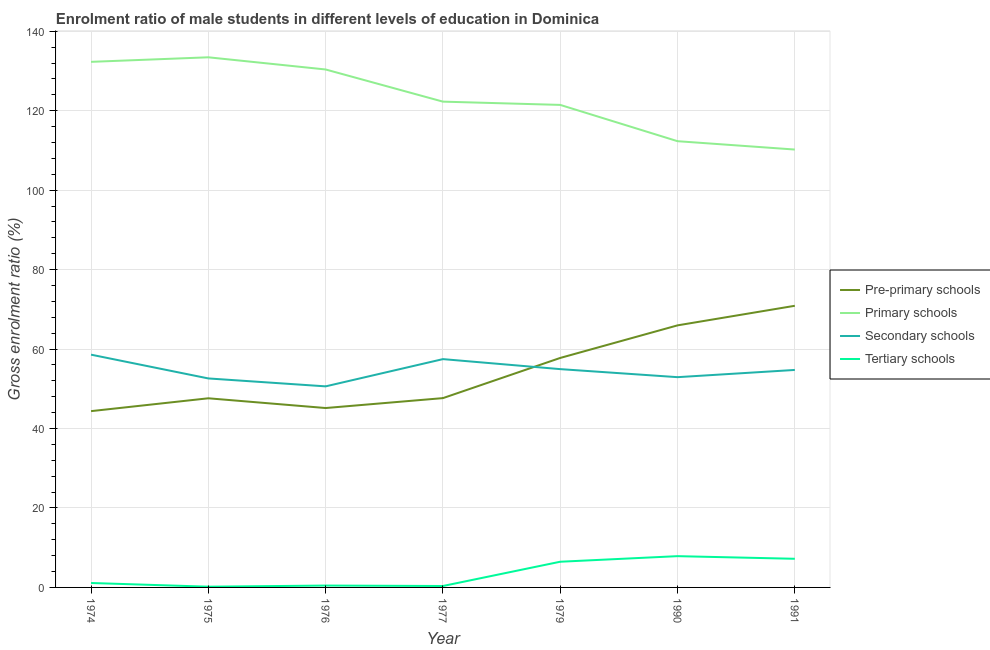Is the number of lines equal to the number of legend labels?
Give a very brief answer. Yes. What is the gross enrolment ratio(female) in pre-primary schools in 1990?
Ensure brevity in your answer.  65.97. Across all years, what is the maximum gross enrolment ratio(female) in primary schools?
Provide a succinct answer. 133.45. Across all years, what is the minimum gross enrolment ratio(female) in pre-primary schools?
Keep it short and to the point. 44.38. In which year was the gross enrolment ratio(female) in tertiary schools maximum?
Offer a terse response. 1990. In which year was the gross enrolment ratio(female) in secondary schools minimum?
Offer a very short reply. 1976. What is the total gross enrolment ratio(female) in secondary schools in the graph?
Make the answer very short. 381.93. What is the difference between the gross enrolment ratio(female) in tertiary schools in 1974 and that in 1976?
Your answer should be compact. 0.64. What is the difference between the gross enrolment ratio(female) in secondary schools in 1975 and the gross enrolment ratio(female) in pre-primary schools in 1974?
Keep it short and to the point. 8.23. What is the average gross enrolment ratio(female) in pre-primary schools per year?
Give a very brief answer. 54.21. In the year 1990, what is the difference between the gross enrolment ratio(female) in secondary schools and gross enrolment ratio(female) in tertiary schools?
Provide a succinct answer. 45.06. In how many years, is the gross enrolment ratio(female) in primary schools greater than 24 %?
Make the answer very short. 7. What is the ratio of the gross enrolment ratio(female) in secondary schools in 1979 to that in 1990?
Your answer should be compact. 1.04. Is the gross enrolment ratio(female) in pre-primary schools in 1975 less than that in 1977?
Keep it short and to the point. Yes. Is the difference between the gross enrolment ratio(female) in tertiary schools in 1974 and 1977 greater than the difference between the gross enrolment ratio(female) in pre-primary schools in 1974 and 1977?
Offer a terse response. Yes. What is the difference between the highest and the second highest gross enrolment ratio(female) in tertiary schools?
Your response must be concise. 0.66. What is the difference between the highest and the lowest gross enrolment ratio(female) in secondary schools?
Offer a terse response. 7.98. In how many years, is the gross enrolment ratio(female) in pre-primary schools greater than the average gross enrolment ratio(female) in pre-primary schools taken over all years?
Give a very brief answer. 3. Is it the case that in every year, the sum of the gross enrolment ratio(female) in pre-primary schools and gross enrolment ratio(female) in primary schools is greater than the gross enrolment ratio(female) in secondary schools?
Provide a succinct answer. Yes. Does the gross enrolment ratio(female) in tertiary schools monotonically increase over the years?
Give a very brief answer. No. Is the gross enrolment ratio(female) in primary schools strictly greater than the gross enrolment ratio(female) in tertiary schools over the years?
Your answer should be very brief. Yes. Is the gross enrolment ratio(female) in primary schools strictly less than the gross enrolment ratio(female) in pre-primary schools over the years?
Ensure brevity in your answer.  No. How many lines are there?
Provide a succinct answer. 4. How many years are there in the graph?
Provide a succinct answer. 7. Does the graph contain any zero values?
Make the answer very short. No. Where does the legend appear in the graph?
Give a very brief answer. Center right. How are the legend labels stacked?
Provide a short and direct response. Vertical. What is the title of the graph?
Your answer should be compact. Enrolment ratio of male students in different levels of education in Dominica. What is the label or title of the Y-axis?
Keep it short and to the point. Gross enrolment ratio (%). What is the Gross enrolment ratio (%) of Pre-primary schools in 1974?
Your answer should be very brief. 44.38. What is the Gross enrolment ratio (%) in Primary schools in 1974?
Provide a succinct answer. 132.31. What is the Gross enrolment ratio (%) of Secondary schools in 1974?
Keep it short and to the point. 58.59. What is the Gross enrolment ratio (%) of Tertiary schools in 1974?
Your answer should be compact. 1.11. What is the Gross enrolment ratio (%) in Pre-primary schools in 1975?
Keep it short and to the point. 47.61. What is the Gross enrolment ratio (%) of Primary schools in 1975?
Offer a terse response. 133.45. What is the Gross enrolment ratio (%) in Secondary schools in 1975?
Keep it short and to the point. 52.61. What is the Gross enrolment ratio (%) of Tertiary schools in 1975?
Offer a terse response. 0.19. What is the Gross enrolment ratio (%) in Pre-primary schools in 1976?
Your answer should be very brief. 45.16. What is the Gross enrolment ratio (%) in Primary schools in 1976?
Your response must be concise. 130.39. What is the Gross enrolment ratio (%) in Secondary schools in 1976?
Give a very brief answer. 50.62. What is the Gross enrolment ratio (%) in Tertiary schools in 1976?
Keep it short and to the point. 0.47. What is the Gross enrolment ratio (%) of Pre-primary schools in 1977?
Offer a very short reply. 47.66. What is the Gross enrolment ratio (%) in Primary schools in 1977?
Provide a short and direct response. 122.29. What is the Gross enrolment ratio (%) in Secondary schools in 1977?
Provide a succinct answer. 57.47. What is the Gross enrolment ratio (%) of Tertiary schools in 1977?
Keep it short and to the point. 0.36. What is the Gross enrolment ratio (%) of Pre-primary schools in 1979?
Provide a succinct answer. 57.77. What is the Gross enrolment ratio (%) in Primary schools in 1979?
Offer a terse response. 121.47. What is the Gross enrolment ratio (%) of Secondary schools in 1979?
Ensure brevity in your answer.  54.95. What is the Gross enrolment ratio (%) of Tertiary schools in 1979?
Ensure brevity in your answer.  6.47. What is the Gross enrolment ratio (%) of Pre-primary schools in 1990?
Keep it short and to the point. 65.97. What is the Gross enrolment ratio (%) of Primary schools in 1990?
Give a very brief answer. 112.33. What is the Gross enrolment ratio (%) of Secondary schools in 1990?
Make the answer very short. 52.93. What is the Gross enrolment ratio (%) of Tertiary schools in 1990?
Your answer should be compact. 7.87. What is the Gross enrolment ratio (%) in Pre-primary schools in 1991?
Offer a very short reply. 70.9. What is the Gross enrolment ratio (%) of Primary schools in 1991?
Make the answer very short. 110.23. What is the Gross enrolment ratio (%) in Secondary schools in 1991?
Provide a short and direct response. 54.75. What is the Gross enrolment ratio (%) in Tertiary schools in 1991?
Provide a short and direct response. 7.21. Across all years, what is the maximum Gross enrolment ratio (%) of Pre-primary schools?
Your answer should be compact. 70.9. Across all years, what is the maximum Gross enrolment ratio (%) of Primary schools?
Make the answer very short. 133.45. Across all years, what is the maximum Gross enrolment ratio (%) in Secondary schools?
Make the answer very short. 58.59. Across all years, what is the maximum Gross enrolment ratio (%) in Tertiary schools?
Offer a very short reply. 7.87. Across all years, what is the minimum Gross enrolment ratio (%) of Pre-primary schools?
Give a very brief answer. 44.38. Across all years, what is the minimum Gross enrolment ratio (%) in Primary schools?
Your answer should be compact. 110.23. Across all years, what is the minimum Gross enrolment ratio (%) in Secondary schools?
Ensure brevity in your answer.  50.62. Across all years, what is the minimum Gross enrolment ratio (%) of Tertiary schools?
Provide a short and direct response. 0.19. What is the total Gross enrolment ratio (%) of Pre-primary schools in the graph?
Provide a succinct answer. 379.45. What is the total Gross enrolment ratio (%) of Primary schools in the graph?
Make the answer very short. 862.47. What is the total Gross enrolment ratio (%) in Secondary schools in the graph?
Give a very brief answer. 381.93. What is the total Gross enrolment ratio (%) in Tertiary schools in the graph?
Offer a terse response. 23.68. What is the difference between the Gross enrolment ratio (%) in Pre-primary schools in 1974 and that in 1975?
Give a very brief answer. -3.23. What is the difference between the Gross enrolment ratio (%) of Primary schools in 1974 and that in 1975?
Offer a terse response. -1.15. What is the difference between the Gross enrolment ratio (%) in Secondary schools in 1974 and that in 1975?
Offer a terse response. 5.99. What is the difference between the Gross enrolment ratio (%) of Tertiary schools in 1974 and that in 1975?
Offer a terse response. 0.93. What is the difference between the Gross enrolment ratio (%) of Pre-primary schools in 1974 and that in 1976?
Offer a very short reply. -0.78. What is the difference between the Gross enrolment ratio (%) of Primary schools in 1974 and that in 1976?
Keep it short and to the point. 1.92. What is the difference between the Gross enrolment ratio (%) in Secondary schools in 1974 and that in 1976?
Offer a very short reply. 7.98. What is the difference between the Gross enrolment ratio (%) of Tertiary schools in 1974 and that in 1976?
Provide a short and direct response. 0.64. What is the difference between the Gross enrolment ratio (%) of Pre-primary schools in 1974 and that in 1977?
Give a very brief answer. -3.28. What is the difference between the Gross enrolment ratio (%) of Primary schools in 1974 and that in 1977?
Your response must be concise. 10.02. What is the difference between the Gross enrolment ratio (%) in Secondary schools in 1974 and that in 1977?
Your response must be concise. 1.12. What is the difference between the Gross enrolment ratio (%) in Tertiary schools in 1974 and that in 1977?
Provide a succinct answer. 0.76. What is the difference between the Gross enrolment ratio (%) of Pre-primary schools in 1974 and that in 1979?
Provide a short and direct response. -13.39. What is the difference between the Gross enrolment ratio (%) in Primary schools in 1974 and that in 1979?
Make the answer very short. 10.84. What is the difference between the Gross enrolment ratio (%) of Secondary schools in 1974 and that in 1979?
Ensure brevity in your answer.  3.64. What is the difference between the Gross enrolment ratio (%) of Tertiary schools in 1974 and that in 1979?
Provide a succinct answer. -5.35. What is the difference between the Gross enrolment ratio (%) of Pre-primary schools in 1974 and that in 1990?
Your answer should be very brief. -21.59. What is the difference between the Gross enrolment ratio (%) in Primary schools in 1974 and that in 1990?
Your response must be concise. 19.97. What is the difference between the Gross enrolment ratio (%) of Secondary schools in 1974 and that in 1990?
Make the answer very short. 5.66. What is the difference between the Gross enrolment ratio (%) in Tertiary schools in 1974 and that in 1990?
Give a very brief answer. -6.76. What is the difference between the Gross enrolment ratio (%) in Pre-primary schools in 1974 and that in 1991?
Ensure brevity in your answer.  -26.52. What is the difference between the Gross enrolment ratio (%) of Primary schools in 1974 and that in 1991?
Provide a succinct answer. 22.08. What is the difference between the Gross enrolment ratio (%) of Secondary schools in 1974 and that in 1991?
Offer a terse response. 3.85. What is the difference between the Gross enrolment ratio (%) of Tertiary schools in 1974 and that in 1991?
Make the answer very short. -6.1. What is the difference between the Gross enrolment ratio (%) of Pre-primary schools in 1975 and that in 1976?
Keep it short and to the point. 2.45. What is the difference between the Gross enrolment ratio (%) of Primary schools in 1975 and that in 1976?
Offer a terse response. 3.07. What is the difference between the Gross enrolment ratio (%) in Secondary schools in 1975 and that in 1976?
Give a very brief answer. 1.99. What is the difference between the Gross enrolment ratio (%) in Tertiary schools in 1975 and that in 1976?
Provide a short and direct response. -0.28. What is the difference between the Gross enrolment ratio (%) in Pre-primary schools in 1975 and that in 1977?
Keep it short and to the point. -0.04. What is the difference between the Gross enrolment ratio (%) in Primary schools in 1975 and that in 1977?
Provide a short and direct response. 11.16. What is the difference between the Gross enrolment ratio (%) of Secondary schools in 1975 and that in 1977?
Offer a very short reply. -4.86. What is the difference between the Gross enrolment ratio (%) in Tertiary schools in 1975 and that in 1977?
Ensure brevity in your answer.  -0.17. What is the difference between the Gross enrolment ratio (%) in Pre-primary schools in 1975 and that in 1979?
Offer a terse response. -10.16. What is the difference between the Gross enrolment ratio (%) in Primary schools in 1975 and that in 1979?
Provide a succinct answer. 11.98. What is the difference between the Gross enrolment ratio (%) of Secondary schools in 1975 and that in 1979?
Provide a short and direct response. -2.34. What is the difference between the Gross enrolment ratio (%) of Tertiary schools in 1975 and that in 1979?
Provide a succinct answer. -6.28. What is the difference between the Gross enrolment ratio (%) in Pre-primary schools in 1975 and that in 1990?
Keep it short and to the point. -18.36. What is the difference between the Gross enrolment ratio (%) in Primary schools in 1975 and that in 1990?
Your response must be concise. 21.12. What is the difference between the Gross enrolment ratio (%) of Secondary schools in 1975 and that in 1990?
Provide a succinct answer. -0.32. What is the difference between the Gross enrolment ratio (%) of Tertiary schools in 1975 and that in 1990?
Make the answer very short. -7.69. What is the difference between the Gross enrolment ratio (%) in Pre-primary schools in 1975 and that in 1991?
Your answer should be very brief. -23.29. What is the difference between the Gross enrolment ratio (%) in Primary schools in 1975 and that in 1991?
Give a very brief answer. 23.22. What is the difference between the Gross enrolment ratio (%) in Secondary schools in 1975 and that in 1991?
Offer a terse response. -2.14. What is the difference between the Gross enrolment ratio (%) in Tertiary schools in 1975 and that in 1991?
Offer a terse response. -7.03. What is the difference between the Gross enrolment ratio (%) in Pre-primary schools in 1976 and that in 1977?
Offer a terse response. -2.5. What is the difference between the Gross enrolment ratio (%) in Primary schools in 1976 and that in 1977?
Offer a very short reply. 8.1. What is the difference between the Gross enrolment ratio (%) of Secondary schools in 1976 and that in 1977?
Offer a very short reply. -6.86. What is the difference between the Gross enrolment ratio (%) of Tertiary schools in 1976 and that in 1977?
Offer a terse response. 0.11. What is the difference between the Gross enrolment ratio (%) in Pre-primary schools in 1976 and that in 1979?
Your response must be concise. -12.61. What is the difference between the Gross enrolment ratio (%) in Primary schools in 1976 and that in 1979?
Give a very brief answer. 8.92. What is the difference between the Gross enrolment ratio (%) in Secondary schools in 1976 and that in 1979?
Provide a succinct answer. -4.34. What is the difference between the Gross enrolment ratio (%) of Tertiary schools in 1976 and that in 1979?
Offer a terse response. -6. What is the difference between the Gross enrolment ratio (%) of Pre-primary schools in 1976 and that in 1990?
Give a very brief answer. -20.81. What is the difference between the Gross enrolment ratio (%) in Primary schools in 1976 and that in 1990?
Provide a succinct answer. 18.05. What is the difference between the Gross enrolment ratio (%) of Secondary schools in 1976 and that in 1990?
Ensure brevity in your answer.  -2.31. What is the difference between the Gross enrolment ratio (%) of Tertiary schools in 1976 and that in 1990?
Provide a succinct answer. -7.4. What is the difference between the Gross enrolment ratio (%) in Pre-primary schools in 1976 and that in 1991?
Your response must be concise. -25.74. What is the difference between the Gross enrolment ratio (%) of Primary schools in 1976 and that in 1991?
Give a very brief answer. 20.16. What is the difference between the Gross enrolment ratio (%) in Secondary schools in 1976 and that in 1991?
Your answer should be very brief. -4.13. What is the difference between the Gross enrolment ratio (%) of Tertiary schools in 1976 and that in 1991?
Ensure brevity in your answer.  -6.74. What is the difference between the Gross enrolment ratio (%) of Pre-primary schools in 1977 and that in 1979?
Provide a succinct answer. -10.11. What is the difference between the Gross enrolment ratio (%) of Primary schools in 1977 and that in 1979?
Your answer should be very brief. 0.82. What is the difference between the Gross enrolment ratio (%) in Secondary schools in 1977 and that in 1979?
Make the answer very short. 2.52. What is the difference between the Gross enrolment ratio (%) of Tertiary schools in 1977 and that in 1979?
Keep it short and to the point. -6.11. What is the difference between the Gross enrolment ratio (%) of Pre-primary schools in 1977 and that in 1990?
Give a very brief answer. -18.31. What is the difference between the Gross enrolment ratio (%) in Primary schools in 1977 and that in 1990?
Ensure brevity in your answer.  9.96. What is the difference between the Gross enrolment ratio (%) in Secondary schools in 1977 and that in 1990?
Give a very brief answer. 4.54. What is the difference between the Gross enrolment ratio (%) in Tertiary schools in 1977 and that in 1990?
Offer a terse response. -7.51. What is the difference between the Gross enrolment ratio (%) of Pre-primary schools in 1977 and that in 1991?
Provide a succinct answer. -23.24. What is the difference between the Gross enrolment ratio (%) of Primary schools in 1977 and that in 1991?
Provide a succinct answer. 12.06. What is the difference between the Gross enrolment ratio (%) of Secondary schools in 1977 and that in 1991?
Provide a succinct answer. 2.72. What is the difference between the Gross enrolment ratio (%) in Tertiary schools in 1977 and that in 1991?
Offer a very short reply. -6.85. What is the difference between the Gross enrolment ratio (%) of Pre-primary schools in 1979 and that in 1990?
Keep it short and to the point. -8.2. What is the difference between the Gross enrolment ratio (%) of Primary schools in 1979 and that in 1990?
Your response must be concise. 9.14. What is the difference between the Gross enrolment ratio (%) of Secondary schools in 1979 and that in 1990?
Give a very brief answer. 2.02. What is the difference between the Gross enrolment ratio (%) in Tertiary schools in 1979 and that in 1990?
Your answer should be compact. -1.4. What is the difference between the Gross enrolment ratio (%) of Pre-primary schools in 1979 and that in 1991?
Make the answer very short. -13.13. What is the difference between the Gross enrolment ratio (%) of Primary schools in 1979 and that in 1991?
Your answer should be very brief. 11.24. What is the difference between the Gross enrolment ratio (%) in Secondary schools in 1979 and that in 1991?
Keep it short and to the point. 0.2. What is the difference between the Gross enrolment ratio (%) in Tertiary schools in 1979 and that in 1991?
Make the answer very short. -0.74. What is the difference between the Gross enrolment ratio (%) of Pre-primary schools in 1990 and that in 1991?
Offer a terse response. -4.93. What is the difference between the Gross enrolment ratio (%) in Primary schools in 1990 and that in 1991?
Your answer should be compact. 2.1. What is the difference between the Gross enrolment ratio (%) in Secondary schools in 1990 and that in 1991?
Offer a very short reply. -1.82. What is the difference between the Gross enrolment ratio (%) in Tertiary schools in 1990 and that in 1991?
Your response must be concise. 0.66. What is the difference between the Gross enrolment ratio (%) in Pre-primary schools in 1974 and the Gross enrolment ratio (%) in Primary schools in 1975?
Your response must be concise. -89.07. What is the difference between the Gross enrolment ratio (%) in Pre-primary schools in 1974 and the Gross enrolment ratio (%) in Secondary schools in 1975?
Offer a terse response. -8.23. What is the difference between the Gross enrolment ratio (%) in Pre-primary schools in 1974 and the Gross enrolment ratio (%) in Tertiary schools in 1975?
Give a very brief answer. 44.19. What is the difference between the Gross enrolment ratio (%) in Primary schools in 1974 and the Gross enrolment ratio (%) in Secondary schools in 1975?
Keep it short and to the point. 79.7. What is the difference between the Gross enrolment ratio (%) in Primary schools in 1974 and the Gross enrolment ratio (%) in Tertiary schools in 1975?
Your answer should be very brief. 132.12. What is the difference between the Gross enrolment ratio (%) of Secondary schools in 1974 and the Gross enrolment ratio (%) of Tertiary schools in 1975?
Provide a short and direct response. 58.41. What is the difference between the Gross enrolment ratio (%) in Pre-primary schools in 1974 and the Gross enrolment ratio (%) in Primary schools in 1976?
Offer a terse response. -86.01. What is the difference between the Gross enrolment ratio (%) of Pre-primary schools in 1974 and the Gross enrolment ratio (%) of Secondary schools in 1976?
Provide a succinct answer. -6.24. What is the difference between the Gross enrolment ratio (%) of Pre-primary schools in 1974 and the Gross enrolment ratio (%) of Tertiary schools in 1976?
Your response must be concise. 43.91. What is the difference between the Gross enrolment ratio (%) of Primary schools in 1974 and the Gross enrolment ratio (%) of Secondary schools in 1976?
Offer a terse response. 81.69. What is the difference between the Gross enrolment ratio (%) of Primary schools in 1974 and the Gross enrolment ratio (%) of Tertiary schools in 1976?
Your answer should be very brief. 131.84. What is the difference between the Gross enrolment ratio (%) of Secondary schools in 1974 and the Gross enrolment ratio (%) of Tertiary schools in 1976?
Offer a very short reply. 58.12. What is the difference between the Gross enrolment ratio (%) in Pre-primary schools in 1974 and the Gross enrolment ratio (%) in Primary schools in 1977?
Make the answer very short. -77.91. What is the difference between the Gross enrolment ratio (%) in Pre-primary schools in 1974 and the Gross enrolment ratio (%) in Secondary schools in 1977?
Your answer should be compact. -13.09. What is the difference between the Gross enrolment ratio (%) in Pre-primary schools in 1974 and the Gross enrolment ratio (%) in Tertiary schools in 1977?
Offer a terse response. 44.02. What is the difference between the Gross enrolment ratio (%) of Primary schools in 1974 and the Gross enrolment ratio (%) of Secondary schools in 1977?
Give a very brief answer. 74.83. What is the difference between the Gross enrolment ratio (%) in Primary schools in 1974 and the Gross enrolment ratio (%) in Tertiary schools in 1977?
Provide a succinct answer. 131.95. What is the difference between the Gross enrolment ratio (%) of Secondary schools in 1974 and the Gross enrolment ratio (%) of Tertiary schools in 1977?
Make the answer very short. 58.24. What is the difference between the Gross enrolment ratio (%) in Pre-primary schools in 1974 and the Gross enrolment ratio (%) in Primary schools in 1979?
Make the answer very short. -77.09. What is the difference between the Gross enrolment ratio (%) in Pre-primary schools in 1974 and the Gross enrolment ratio (%) in Secondary schools in 1979?
Your answer should be compact. -10.57. What is the difference between the Gross enrolment ratio (%) of Pre-primary schools in 1974 and the Gross enrolment ratio (%) of Tertiary schools in 1979?
Give a very brief answer. 37.91. What is the difference between the Gross enrolment ratio (%) of Primary schools in 1974 and the Gross enrolment ratio (%) of Secondary schools in 1979?
Your answer should be compact. 77.35. What is the difference between the Gross enrolment ratio (%) in Primary schools in 1974 and the Gross enrolment ratio (%) in Tertiary schools in 1979?
Offer a terse response. 125.84. What is the difference between the Gross enrolment ratio (%) in Secondary schools in 1974 and the Gross enrolment ratio (%) in Tertiary schools in 1979?
Keep it short and to the point. 52.13. What is the difference between the Gross enrolment ratio (%) of Pre-primary schools in 1974 and the Gross enrolment ratio (%) of Primary schools in 1990?
Make the answer very short. -67.95. What is the difference between the Gross enrolment ratio (%) in Pre-primary schools in 1974 and the Gross enrolment ratio (%) in Secondary schools in 1990?
Provide a short and direct response. -8.55. What is the difference between the Gross enrolment ratio (%) of Pre-primary schools in 1974 and the Gross enrolment ratio (%) of Tertiary schools in 1990?
Your answer should be very brief. 36.51. What is the difference between the Gross enrolment ratio (%) of Primary schools in 1974 and the Gross enrolment ratio (%) of Secondary schools in 1990?
Make the answer very short. 79.38. What is the difference between the Gross enrolment ratio (%) in Primary schools in 1974 and the Gross enrolment ratio (%) in Tertiary schools in 1990?
Ensure brevity in your answer.  124.43. What is the difference between the Gross enrolment ratio (%) in Secondary schools in 1974 and the Gross enrolment ratio (%) in Tertiary schools in 1990?
Offer a very short reply. 50.72. What is the difference between the Gross enrolment ratio (%) of Pre-primary schools in 1974 and the Gross enrolment ratio (%) of Primary schools in 1991?
Offer a very short reply. -65.85. What is the difference between the Gross enrolment ratio (%) in Pre-primary schools in 1974 and the Gross enrolment ratio (%) in Secondary schools in 1991?
Offer a very short reply. -10.37. What is the difference between the Gross enrolment ratio (%) in Pre-primary schools in 1974 and the Gross enrolment ratio (%) in Tertiary schools in 1991?
Provide a succinct answer. 37.17. What is the difference between the Gross enrolment ratio (%) of Primary schools in 1974 and the Gross enrolment ratio (%) of Secondary schools in 1991?
Your response must be concise. 77.56. What is the difference between the Gross enrolment ratio (%) of Primary schools in 1974 and the Gross enrolment ratio (%) of Tertiary schools in 1991?
Offer a very short reply. 125.1. What is the difference between the Gross enrolment ratio (%) of Secondary schools in 1974 and the Gross enrolment ratio (%) of Tertiary schools in 1991?
Give a very brief answer. 51.38. What is the difference between the Gross enrolment ratio (%) in Pre-primary schools in 1975 and the Gross enrolment ratio (%) in Primary schools in 1976?
Your response must be concise. -82.77. What is the difference between the Gross enrolment ratio (%) of Pre-primary schools in 1975 and the Gross enrolment ratio (%) of Secondary schools in 1976?
Offer a very short reply. -3. What is the difference between the Gross enrolment ratio (%) of Pre-primary schools in 1975 and the Gross enrolment ratio (%) of Tertiary schools in 1976?
Your answer should be compact. 47.14. What is the difference between the Gross enrolment ratio (%) in Primary schools in 1975 and the Gross enrolment ratio (%) in Secondary schools in 1976?
Offer a terse response. 82.84. What is the difference between the Gross enrolment ratio (%) of Primary schools in 1975 and the Gross enrolment ratio (%) of Tertiary schools in 1976?
Give a very brief answer. 132.98. What is the difference between the Gross enrolment ratio (%) in Secondary schools in 1975 and the Gross enrolment ratio (%) in Tertiary schools in 1976?
Your response must be concise. 52.14. What is the difference between the Gross enrolment ratio (%) in Pre-primary schools in 1975 and the Gross enrolment ratio (%) in Primary schools in 1977?
Your response must be concise. -74.68. What is the difference between the Gross enrolment ratio (%) in Pre-primary schools in 1975 and the Gross enrolment ratio (%) in Secondary schools in 1977?
Offer a terse response. -9.86. What is the difference between the Gross enrolment ratio (%) of Pre-primary schools in 1975 and the Gross enrolment ratio (%) of Tertiary schools in 1977?
Your answer should be very brief. 47.25. What is the difference between the Gross enrolment ratio (%) of Primary schools in 1975 and the Gross enrolment ratio (%) of Secondary schools in 1977?
Offer a terse response. 75.98. What is the difference between the Gross enrolment ratio (%) in Primary schools in 1975 and the Gross enrolment ratio (%) in Tertiary schools in 1977?
Provide a succinct answer. 133.09. What is the difference between the Gross enrolment ratio (%) in Secondary schools in 1975 and the Gross enrolment ratio (%) in Tertiary schools in 1977?
Offer a very short reply. 52.25. What is the difference between the Gross enrolment ratio (%) in Pre-primary schools in 1975 and the Gross enrolment ratio (%) in Primary schools in 1979?
Your answer should be very brief. -73.86. What is the difference between the Gross enrolment ratio (%) of Pre-primary schools in 1975 and the Gross enrolment ratio (%) of Secondary schools in 1979?
Offer a terse response. -7.34. What is the difference between the Gross enrolment ratio (%) in Pre-primary schools in 1975 and the Gross enrolment ratio (%) in Tertiary schools in 1979?
Keep it short and to the point. 41.14. What is the difference between the Gross enrolment ratio (%) of Primary schools in 1975 and the Gross enrolment ratio (%) of Secondary schools in 1979?
Provide a short and direct response. 78.5. What is the difference between the Gross enrolment ratio (%) of Primary schools in 1975 and the Gross enrolment ratio (%) of Tertiary schools in 1979?
Give a very brief answer. 126.98. What is the difference between the Gross enrolment ratio (%) in Secondary schools in 1975 and the Gross enrolment ratio (%) in Tertiary schools in 1979?
Provide a short and direct response. 46.14. What is the difference between the Gross enrolment ratio (%) of Pre-primary schools in 1975 and the Gross enrolment ratio (%) of Primary schools in 1990?
Provide a succinct answer. -64.72. What is the difference between the Gross enrolment ratio (%) of Pre-primary schools in 1975 and the Gross enrolment ratio (%) of Secondary schools in 1990?
Your answer should be compact. -5.32. What is the difference between the Gross enrolment ratio (%) of Pre-primary schools in 1975 and the Gross enrolment ratio (%) of Tertiary schools in 1990?
Make the answer very short. 39.74. What is the difference between the Gross enrolment ratio (%) in Primary schools in 1975 and the Gross enrolment ratio (%) in Secondary schools in 1990?
Your answer should be compact. 80.52. What is the difference between the Gross enrolment ratio (%) of Primary schools in 1975 and the Gross enrolment ratio (%) of Tertiary schools in 1990?
Make the answer very short. 125.58. What is the difference between the Gross enrolment ratio (%) of Secondary schools in 1975 and the Gross enrolment ratio (%) of Tertiary schools in 1990?
Keep it short and to the point. 44.74. What is the difference between the Gross enrolment ratio (%) in Pre-primary schools in 1975 and the Gross enrolment ratio (%) in Primary schools in 1991?
Your response must be concise. -62.62. What is the difference between the Gross enrolment ratio (%) of Pre-primary schools in 1975 and the Gross enrolment ratio (%) of Secondary schools in 1991?
Give a very brief answer. -7.14. What is the difference between the Gross enrolment ratio (%) in Pre-primary schools in 1975 and the Gross enrolment ratio (%) in Tertiary schools in 1991?
Your answer should be compact. 40.4. What is the difference between the Gross enrolment ratio (%) in Primary schools in 1975 and the Gross enrolment ratio (%) in Secondary schools in 1991?
Your answer should be very brief. 78.7. What is the difference between the Gross enrolment ratio (%) in Primary schools in 1975 and the Gross enrolment ratio (%) in Tertiary schools in 1991?
Keep it short and to the point. 126.24. What is the difference between the Gross enrolment ratio (%) in Secondary schools in 1975 and the Gross enrolment ratio (%) in Tertiary schools in 1991?
Provide a short and direct response. 45.4. What is the difference between the Gross enrolment ratio (%) in Pre-primary schools in 1976 and the Gross enrolment ratio (%) in Primary schools in 1977?
Give a very brief answer. -77.13. What is the difference between the Gross enrolment ratio (%) in Pre-primary schools in 1976 and the Gross enrolment ratio (%) in Secondary schools in 1977?
Provide a short and direct response. -12.31. What is the difference between the Gross enrolment ratio (%) of Pre-primary schools in 1976 and the Gross enrolment ratio (%) of Tertiary schools in 1977?
Offer a terse response. 44.8. What is the difference between the Gross enrolment ratio (%) in Primary schools in 1976 and the Gross enrolment ratio (%) in Secondary schools in 1977?
Your answer should be compact. 72.91. What is the difference between the Gross enrolment ratio (%) in Primary schools in 1976 and the Gross enrolment ratio (%) in Tertiary schools in 1977?
Your answer should be compact. 130.03. What is the difference between the Gross enrolment ratio (%) in Secondary schools in 1976 and the Gross enrolment ratio (%) in Tertiary schools in 1977?
Offer a very short reply. 50.26. What is the difference between the Gross enrolment ratio (%) in Pre-primary schools in 1976 and the Gross enrolment ratio (%) in Primary schools in 1979?
Keep it short and to the point. -76.31. What is the difference between the Gross enrolment ratio (%) of Pre-primary schools in 1976 and the Gross enrolment ratio (%) of Secondary schools in 1979?
Give a very brief answer. -9.79. What is the difference between the Gross enrolment ratio (%) in Pre-primary schools in 1976 and the Gross enrolment ratio (%) in Tertiary schools in 1979?
Provide a succinct answer. 38.69. What is the difference between the Gross enrolment ratio (%) of Primary schools in 1976 and the Gross enrolment ratio (%) of Secondary schools in 1979?
Your answer should be very brief. 75.43. What is the difference between the Gross enrolment ratio (%) in Primary schools in 1976 and the Gross enrolment ratio (%) in Tertiary schools in 1979?
Keep it short and to the point. 123.92. What is the difference between the Gross enrolment ratio (%) of Secondary schools in 1976 and the Gross enrolment ratio (%) of Tertiary schools in 1979?
Give a very brief answer. 44.15. What is the difference between the Gross enrolment ratio (%) in Pre-primary schools in 1976 and the Gross enrolment ratio (%) in Primary schools in 1990?
Your response must be concise. -67.17. What is the difference between the Gross enrolment ratio (%) in Pre-primary schools in 1976 and the Gross enrolment ratio (%) in Secondary schools in 1990?
Keep it short and to the point. -7.77. What is the difference between the Gross enrolment ratio (%) of Pre-primary schools in 1976 and the Gross enrolment ratio (%) of Tertiary schools in 1990?
Your answer should be very brief. 37.29. What is the difference between the Gross enrolment ratio (%) of Primary schools in 1976 and the Gross enrolment ratio (%) of Secondary schools in 1990?
Your answer should be compact. 77.46. What is the difference between the Gross enrolment ratio (%) in Primary schools in 1976 and the Gross enrolment ratio (%) in Tertiary schools in 1990?
Ensure brevity in your answer.  122.51. What is the difference between the Gross enrolment ratio (%) of Secondary schools in 1976 and the Gross enrolment ratio (%) of Tertiary schools in 1990?
Your response must be concise. 42.74. What is the difference between the Gross enrolment ratio (%) in Pre-primary schools in 1976 and the Gross enrolment ratio (%) in Primary schools in 1991?
Offer a terse response. -65.07. What is the difference between the Gross enrolment ratio (%) in Pre-primary schools in 1976 and the Gross enrolment ratio (%) in Secondary schools in 1991?
Provide a succinct answer. -9.59. What is the difference between the Gross enrolment ratio (%) in Pre-primary schools in 1976 and the Gross enrolment ratio (%) in Tertiary schools in 1991?
Ensure brevity in your answer.  37.95. What is the difference between the Gross enrolment ratio (%) of Primary schools in 1976 and the Gross enrolment ratio (%) of Secondary schools in 1991?
Ensure brevity in your answer.  75.64. What is the difference between the Gross enrolment ratio (%) in Primary schools in 1976 and the Gross enrolment ratio (%) in Tertiary schools in 1991?
Provide a short and direct response. 123.17. What is the difference between the Gross enrolment ratio (%) in Secondary schools in 1976 and the Gross enrolment ratio (%) in Tertiary schools in 1991?
Make the answer very short. 43.41. What is the difference between the Gross enrolment ratio (%) of Pre-primary schools in 1977 and the Gross enrolment ratio (%) of Primary schools in 1979?
Keep it short and to the point. -73.81. What is the difference between the Gross enrolment ratio (%) in Pre-primary schools in 1977 and the Gross enrolment ratio (%) in Secondary schools in 1979?
Your response must be concise. -7.3. What is the difference between the Gross enrolment ratio (%) of Pre-primary schools in 1977 and the Gross enrolment ratio (%) of Tertiary schools in 1979?
Make the answer very short. 41.19. What is the difference between the Gross enrolment ratio (%) of Primary schools in 1977 and the Gross enrolment ratio (%) of Secondary schools in 1979?
Your answer should be very brief. 67.34. What is the difference between the Gross enrolment ratio (%) in Primary schools in 1977 and the Gross enrolment ratio (%) in Tertiary schools in 1979?
Provide a short and direct response. 115.82. What is the difference between the Gross enrolment ratio (%) of Secondary schools in 1977 and the Gross enrolment ratio (%) of Tertiary schools in 1979?
Give a very brief answer. 51. What is the difference between the Gross enrolment ratio (%) of Pre-primary schools in 1977 and the Gross enrolment ratio (%) of Primary schools in 1990?
Provide a short and direct response. -64.68. What is the difference between the Gross enrolment ratio (%) in Pre-primary schools in 1977 and the Gross enrolment ratio (%) in Secondary schools in 1990?
Offer a very short reply. -5.27. What is the difference between the Gross enrolment ratio (%) in Pre-primary schools in 1977 and the Gross enrolment ratio (%) in Tertiary schools in 1990?
Make the answer very short. 39.78. What is the difference between the Gross enrolment ratio (%) of Primary schools in 1977 and the Gross enrolment ratio (%) of Secondary schools in 1990?
Provide a short and direct response. 69.36. What is the difference between the Gross enrolment ratio (%) in Primary schools in 1977 and the Gross enrolment ratio (%) in Tertiary schools in 1990?
Your response must be concise. 114.42. What is the difference between the Gross enrolment ratio (%) of Secondary schools in 1977 and the Gross enrolment ratio (%) of Tertiary schools in 1990?
Offer a very short reply. 49.6. What is the difference between the Gross enrolment ratio (%) of Pre-primary schools in 1977 and the Gross enrolment ratio (%) of Primary schools in 1991?
Offer a terse response. -62.57. What is the difference between the Gross enrolment ratio (%) in Pre-primary schools in 1977 and the Gross enrolment ratio (%) in Secondary schools in 1991?
Offer a very short reply. -7.09. What is the difference between the Gross enrolment ratio (%) in Pre-primary schools in 1977 and the Gross enrolment ratio (%) in Tertiary schools in 1991?
Provide a short and direct response. 40.45. What is the difference between the Gross enrolment ratio (%) in Primary schools in 1977 and the Gross enrolment ratio (%) in Secondary schools in 1991?
Make the answer very short. 67.54. What is the difference between the Gross enrolment ratio (%) in Primary schools in 1977 and the Gross enrolment ratio (%) in Tertiary schools in 1991?
Your response must be concise. 115.08. What is the difference between the Gross enrolment ratio (%) of Secondary schools in 1977 and the Gross enrolment ratio (%) of Tertiary schools in 1991?
Provide a short and direct response. 50.26. What is the difference between the Gross enrolment ratio (%) in Pre-primary schools in 1979 and the Gross enrolment ratio (%) in Primary schools in 1990?
Your answer should be very brief. -54.56. What is the difference between the Gross enrolment ratio (%) of Pre-primary schools in 1979 and the Gross enrolment ratio (%) of Secondary schools in 1990?
Your answer should be compact. 4.84. What is the difference between the Gross enrolment ratio (%) in Pre-primary schools in 1979 and the Gross enrolment ratio (%) in Tertiary schools in 1990?
Your response must be concise. 49.9. What is the difference between the Gross enrolment ratio (%) in Primary schools in 1979 and the Gross enrolment ratio (%) in Secondary schools in 1990?
Make the answer very short. 68.54. What is the difference between the Gross enrolment ratio (%) of Primary schools in 1979 and the Gross enrolment ratio (%) of Tertiary schools in 1990?
Your response must be concise. 113.6. What is the difference between the Gross enrolment ratio (%) of Secondary schools in 1979 and the Gross enrolment ratio (%) of Tertiary schools in 1990?
Offer a very short reply. 47.08. What is the difference between the Gross enrolment ratio (%) of Pre-primary schools in 1979 and the Gross enrolment ratio (%) of Primary schools in 1991?
Your response must be concise. -52.46. What is the difference between the Gross enrolment ratio (%) of Pre-primary schools in 1979 and the Gross enrolment ratio (%) of Secondary schools in 1991?
Offer a very short reply. 3.02. What is the difference between the Gross enrolment ratio (%) of Pre-primary schools in 1979 and the Gross enrolment ratio (%) of Tertiary schools in 1991?
Provide a succinct answer. 50.56. What is the difference between the Gross enrolment ratio (%) in Primary schools in 1979 and the Gross enrolment ratio (%) in Secondary schools in 1991?
Give a very brief answer. 66.72. What is the difference between the Gross enrolment ratio (%) of Primary schools in 1979 and the Gross enrolment ratio (%) of Tertiary schools in 1991?
Provide a succinct answer. 114.26. What is the difference between the Gross enrolment ratio (%) of Secondary schools in 1979 and the Gross enrolment ratio (%) of Tertiary schools in 1991?
Your response must be concise. 47.74. What is the difference between the Gross enrolment ratio (%) of Pre-primary schools in 1990 and the Gross enrolment ratio (%) of Primary schools in 1991?
Keep it short and to the point. -44.26. What is the difference between the Gross enrolment ratio (%) of Pre-primary schools in 1990 and the Gross enrolment ratio (%) of Secondary schools in 1991?
Offer a very short reply. 11.22. What is the difference between the Gross enrolment ratio (%) of Pre-primary schools in 1990 and the Gross enrolment ratio (%) of Tertiary schools in 1991?
Offer a terse response. 58.76. What is the difference between the Gross enrolment ratio (%) in Primary schools in 1990 and the Gross enrolment ratio (%) in Secondary schools in 1991?
Your answer should be very brief. 57.58. What is the difference between the Gross enrolment ratio (%) in Primary schools in 1990 and the Gross enrolment ratio (%) in Tertiary schools in 1991?
Offer a very short reply. 105.12. What is the difference between the Gross enrolment ratio (%) of Secondary schools in 1990 and the Gross enrolment ratio (%) of Tertiary schools in 1991?
Offer a terse response. 45.72. What is the average Gross enrolment ratio (%) in Pre-primary schools per year?
Your answer should be compact. 54.21. What is the average Gross enrolment ratio (%) of Primary schools per year?
Offer a very short reply. 123.21. What is the average Gross enrolment ratio (%) of Secondary schools per year?
Your answer should be very brief. 54.56. What is the average Gross enrolment ratio (%) in Tertiary schools per year?
Offer a terse response. 3.38. In the year 1974, what is the difference between the Gross enrolment ratio (%) of Pre-primary schools and Gross enrolment ratio (%) of Primary schools?
Offer a terse response. -87.93. In the year 1974, what is the difference between the Gross enrolment ratio (%) in Pre-primary schools and Gross enrolment ratio (%) in Secondary schools?
Provide a succinct answer. -14.21. In the year 1974, what is the difference between the Gross enrolment ratio (%) in Pre-primary schools and Gross enrolment ratio (%) in Tertiary schools?
Your response must be concise. 43.27. In the year 1974, what is the difference between the Gross enrolment ratio (%) of Primary schools and Gross enrolment ratio (%) of Secondary schools?
Offer a very short reply. 73.71. In the year 1974, what is the difference between the Gross enrolment ratio (%) in Primary schools and Gross enrolment ratio (%) in Tertiary schools?
Provide a succinct answer. 131.19. In the year 1974, what is the difference between the Gross enrolment ratio (%) in Secondary schools and Gross enrolment ratio (%) in Tertiary schools?
Offer a very short reply. 57.48. In the year 1975, what is the difference between the Gross enrolment ratio (%) in Pre-primary schools and Gross enrolment ratio (%) in Primary schools?
Give a very brief answer. -85.84. In the year 1975, what is the difference between the Gross enrolment ratio (%) in Pre-primary schools and Gross enrolment ratio (%) in Secondary schools?
Your answer should be very brief. -5. In the year 1975, what is the difference between the Gross enrolment ratio (%) in Pre-primary schools and Gross enrolment ratio (%) in Tertiary schools?
Make the answer very short. 47.43. In the year 1975, what is the difference between the Gross enrolment ratio (%) of Primary schools and Gross enrolment ratio (%) of Secondary schools?
Keep it short and to the point. 80.84. In the year 1975, what is the difference between the Gross enrolment ratio (%) of Primary schools and Gross enrolment ratio (%) of Tertiary schools?
Give a very brief answer. 133.27. In the year 1975, what is the difference between the Gross enrolment ratio (%) in Secondary schools and Gross enrolment ratio (%) in Tertiary schools?
Make the answer very short. 52.42. In the year 1976, what is the difference between the Gross enrolment ratio (%) in Pre-primary schools and Gross enrolment ratio (%) in Primary schools?
Your response must be concise. -85.23. In the year 1976, what is the difference between the Gross enrolment ratio (%) of Pre-primary schools and Gross enrolment ratio (%) of Secondary schools?
Keep it short and to the point. -5.46. In the year 1976, what is the difference between the Gross enrolment ratio (%) of Pre-primary schools and Gross enrolment ratio (%) of Tertiary schools?
Make the answer very short. 44.69. In the year 1976, what is the difference between the Gross enrolment ratio (%) in Primary schools and Gross enrolment ratio (%) in Secondary schools?
Make the answer very short. 79.77. In the year 1976, what is the difference between the Gross enrolment ratio (%) in Primary schools and Gross enrolment ratio (%) in Tertiary schools?
Offer a terse response. 129.91. In the year 1976, what is the difference between the Gross enrolment ratio (%) of Secondary schools and Gross enrolment ratio (%) of Tertiary schools?
Make the answer very short. 50.15. In the year 1977, what is the difference between the Gross enrolment ratio (%) of Pre-primary schools and Gross enrolment ratio (%) of Primary schools?
Make the answer very short. -74.63. In the year 1977, what is the difference between the Gross enrolment ratio (%) of Pre-primary schools and Gross enrolment ratio (%) of Secondary schools?
Your response must be concise. -9.82. In the year 1977, what is the difference between the Gross enrolment ratio (%) of Pre-primary schools and Gross enrolment ratio (%) of Tertiary schools?
Keep it short and to the point. 47.3. In the year 1977, what is the difference between the Gross enrolment ratio (%) in Primary schools and Gross enrolment ratio (%) in Secondary schools?
Your answer should be very brief. 64.82. In the year 1977, what is the difference between the Gross enrolment ratio (%) of Primary schools and Gross enrolment ratio (%) of Tertiary schools?
Offer a very short reply. 121.93. In the year 1977, what is the difference between the Gross enrolment ratio (%) of Secondary schools and Gross enrolment ratio (%) of Tertiary schools?
Provide a succinct answer. 57.11. In the year 1979, what is the difference between the Gross enrolment ratio (%) of Pre-primary schools and Gross enrolment ratio (%) of Primary schools?
Your answer should be very brief. -63.7. In the year 1979, what is the difference between the Gross enrolment ratio (%) of Pre-primary schools and Gross enrolment ratio (%) of Secondary schools?
Provide a succinct answer. 2.82. In the year 1979, what is the difference between the Gross enrolment ratio (%) in Pre-primary schools and Gross enrolment ratio (%) in Tertiary schools?
Ensure brevity in your answer.  51.3. In the year 1979, what is the difference between the Gross enrolment ratio (%) of Primary schools and Gross enrolment ratio (%) of Secondary schools?
Ensure brevity in your answer.  66.52. In the year 1979, what is the difference between the Gross enrolment ratio (%) in Primary schools and Gross enrolment ratio (%) in Tertiary schools?
Make the answer very short. 115. In the year 1979, what is the difference between the Gross enrolment ratio (%) of Secondary schools and Gross enrolment ratio (%) of Tertiary schools?
Offer a terse response. 48.48. In the year 1990, what is the difference between the Gross enrolment ratio (%) of Pre-primary schools and Gross enrolment ratio (%) of Primary schools?
Your answer should be compact. -46.36. In the year 1990, what is the difference between the Gross enrolment ratio (%) in Pre-primary schools and Gross enrolment ratio (%) in Secondary schools?
Provide a succinct answer. 13.04. In the year 1990, what is the difference between the Gross enrolment ratio (%) of Pre-primary schools and Gross enrolment ratio (%) of Tertiary schools?
Your response must be concise. 58.1. In the year 1990, what is the difference between the Gross enrolment ratio (%) in Primary schools and Gross enrolment ratio (%) in Secondary schools?
Keep it short and to the point. 59.4. In the year 1990, what is the difference between the Gross enrolment ratio (%) of Primary schools and Gross enrolment ratio (%) of Tertiary schools?
Provide a short and direct response. 104.46. In the year 1990, what is the difference between the Gross enrolment ratio (%) in Secondary schools and Gross enrolment ratio (%) in Tertiary schools?
Your answer should be compact. 45.06. In the year 1991, what is the difference between the Gross enrolment ratio (%) in Pre-primary schools and Gross enrolment ratio (%) in Primary schools?
Your response must be concise. -39.33. In the year 1991, what is the difference between the Gross enrolment ratio (%) of Pre-primary schools and Gross enrolment ratio (%) of Secondary schools?
Your answer should be compact. 16.15. In the year 1991, what is the difference between the Gross enrolment ratio (%) of Pre-primary schools and Gross enrolment ratio (%) of Tertiary schools?
Give a very brief answer. 63.69. In the year 1991, what is the difference between the Gross enrolment ratio (%) of Primary schools and Gross enrolment ratio (%) of Secondary schools?
Ensure brevity in your answer.  55.48. In the year 1991, what is the difference between the Gross enrolment ratio (%) of Primary schools and Gross enrolment ratio (%) of Tertiary schools?
Provide a short and direct response. 103.02. In the year 1991, what is the difference between the Gross enrolment ratio (%) in Secondary schools and Gross enrolment ratio (%) in Tertiary schools?
Provide a short and direct response. 47.54. What is the ratio of the Gross enrolment ratio (%) in Pre-primary schools in 1974 to that in 1975?
Your response must be concise. 0.93. What is the ratio of the Gross enrolment ratio (%) in Secondary schools in 1974 to that in 1975?
Keep it short and to the point. 1.11. What is the ratio of the Gross enrolment ratio (%) in Tertiary schools in 1974 to that in 1975?
Your answer should be very brief. 5.99. What is the ratio of the Gross enrolment ratio (%) of Pre-primary schools in 1974 to that in 1976?
Your response must be concise. 0.98. What is the ratio of the Gross enrolment ratio (%) of Primary schools in 1974 to that in 1976?
Give a very brief answer. 1.01. What is the ratio of the Gross enrolment ratio (%) in Secondary schools in 1974 to that in 1976?
Keep it short and to the point. 1.16. What is the ratio of the Gross enrolment ratio (%) in Tertiary schools in 1974 to that in 1976?
Ensure brevity in your answer.  2.37. What is the ratio of the Gross enrolment ratio (%) of Pre-primary schools in 1974 to that in 1977?
Make the answer very short. 0.93. What is the ratio of the Gross enrolment ratio (%) of Primary schools in 1974 to that in 1977?
Provide a short and direct response. 1.08. What is the ratio of the Gross enrolment ratio (%) of Secondary schools in 1974 to that in 1977?
Make the answer very short. 1.02. What is the ratio of the Gross enrolment ratio (%) in Tertiary schools in 1974 to that in 1977?
Ensure brevity in your answer.  3.1. What is the ratio of the Gross enrolment ratio (%) in Pre-primary schools in 1974 to that in 1979?
Provide a succinct answer. 0.77. What is the ratio of the Gross enrolment ratio (%) in Primary schools in 1974 to that in 1979?
Give a very brief answer. 1.09. What is the ratio of the Gross enrolment ratio (%) in Secondary schools in 1974 to that in 1979?
Offer a very short reply. 1.07. What is the ratio of the Gross enrolment ratio (%) of Tertiary schools in 1974 to that in 1979?
Provide a succinct answer. 0.17. What is the ratio of the Gross enrolment ratio (%) of Pre-primary schools in 1974 to that in 1990?
Make the answer very short. 0.67. What is the ratio of the Gross enrolment ratio (%) of Primary schools in 1974 to that in 1990?
Your response must be concise. 1.18. What is the ratio of the Gross enrolment ratio (%) of Secondary schools in 1974 to that in 1990?
Ensure brevity in your answer.  1.11. What is the ratio of the Gross enrolment ratio (%) of Tertiary schools in 1974 to that in 1990?
Your answer should be very brief. 0.14. What is the ratio of the Gross enrolment ratio (%) of Pre-primary schools in 1974 to that in 1991?
Your answer should be compact. 0.63. What is the ratio of the Gross enrolment ratio (%) in Primary schools in 1974 to that in 1991?
Offer a terse response. 1.2. What is the ratio of the Gross enrolment ratio (%) of Secondary schools in 1974 to that in 1991?
Your answer should be compact. 1.07. What is the ratio of the Gross enrolment ratio (%) in Tertiary schools in 1974 to that in 1991?
Provide a short and direct response. 0.15. What is the ratio of the Gross enrolment ratio (%) in Pre-primary schools in 1975 to that in 1976?
Your response must be concise. 1.05. What is the ratio of the Gross enrolment ratio (%) in Primary schools in 1975 to that in 1976?
Keep it short and to the point. 1.02. What is the ratio of the Gross enrolment ratio (%) in Secondary schools in 1975 to that in 1976?
Your answer should be compact. 1.04. What is the ratio of the Gross enrolment ratio (%) in Tertiary schools in 1975 to that in 1976?
Offer a very short reply. 0.4. What is the ratio of the Gross enrolment ratio (%) in Pre-primary schools in 1975 to that in 1977?
Ensure brevity in your answer.  1. What is the ratio of the Gross enrolment ratio (%) in Primary schools in 1975 to that in 1977?
Give a very brief answer. 1.09. What is the ratio of the Gross enrolment ratio (%) in Secondary schools in 1975 to that in 1977?
Provide a succinct answer. 0.92. What is the ratio of the Gross enrolment ratio (%) of Tertiary schools in 1975 to that in 1977?
Your answer should be very brief. 0.52. What is the ratio of the Gross enrolment ratio (%) in Pre-primary schools in 1975 to that in 1979?
Ensure brevity in your answer.  0.82. What is the ratio of the Gross enrolment ratio (%) in Primary schools in 1975 to that in 1979?
Ensure brevity in your answer.  1.1. What is the ratio of the Gross enrolment ratio (%) of Secondary schools in 1975 to that in 1979?
Offer a terse response. 0.96. What is the ratio of the Gross enrolment ratio (%) in Tertiary schools in 1975 to that in 1979?
Offer a terse response. 0.03. What is the ratio of the Gross enrolment ratio (%) of Pre-primary schools in 1975 to that in 1990?
Provide a short and direct response. 0.72. What is the ratio of the Gross enrolment ratio (%) in Primary schools in 1975 to that in 1990?
Give a very brief answer. 1.19. What is the ratio of the Gross enrolment ratio (%) in Tertiary schools in 1975 to that in 1990?
Your response must be concise. 0.02. What is the ratio of the Gross enrolment ratio (%) in Pre-primary schools in 1975 to that in 1991?
Offer a very short reply. 0.67. What is the ratio of the Gross enrolment ratio (%) in Primary schools in 1975 to that in 1991?
Your response must be concise. 1.21. What is the ratio of the Gross enrolment ratio (%) of Secondary schools in 1975 to that in 1991?
Your answer should be compact. 0.96. What is the ratio of the Gross enrolment ratio (%) of Tertiary schools in 1975 to that in 1991?
Your response must be concise. 0.03. What is the ratio of the Gross enrolment ratio (%) of Pre-primary schools in 1976 to that in 1977?
Offer a very short reply. 0.95. What is the ratio of the Gross enrolment ratio (%) of Primary schools in 1976 to that in 1977?
Ensure brevity in your answer.  1.07. What is the ratio of the Gross enrolment ratio (%) in Secondary schools in 1976 to that in 1977?
Keep it short and to the point. 0.88. What is the ratio of the Gross enrolment ratio (%) of Tertiary schools in 1976 to that in 1977?
Your response must be concise. 1.31. What is the ratio of the Gross enrolment ratio (%) in Pre-primary schools in 1976 to that in 1979?
Give a very brief answer. 0.78. What is the ratio of the Gross enrolment ratio (%) of Primary schools in 1976 to that in 1979?
Your answer should be compact. 1.07. What is the ratio of the Gross enrolment ratio (%) of Secondary schools in 1976 to that in 1979?
Your answer should be compact. 0.92. What is the ratio of the Gross enrolment ratio (%) of Tertiary schools in 1976 to that in 1979?
Ensure brevity in your answer.  0.07. What is the ratio of the Gross enrolment ratio (%) of Pre-primary schools in 1976 to that in 1990?
Make the answer very short. 0.68. What is the ratio of the Gross enrolment ratio (%) of Primary schools in 1976 to that in 1990?
Keep it short and to the point. 1.16. What is the ratio of the Gross enrolment ratio (%) in Secondary schools in 1976 to that in 1990?
Provide a succinct answer. 0.96. What is the ratio of the Gross enrolment ratio (%) in Tertiary schools in 1976 to that in 1990?
Keep it short and to the point. 0.06. What is the ratio of the Gross enrolment ratio (%) in Pre-primary schools in 1976 to that in 1991?
Keep it short and to the point. 0.64. What is the ratio of the Gross enrolment ratio (%) of Primary schools in 1976 to that in 1991?
Provide a succinct answer. 1.18. What is the ratio of the Gross enrolment ratio (%) of Secondary schools in 1976 to that in 1991?
Offer a terse response. 0.92. What is the ratio of the Gross enrolment ratio (%) of Tertiary schools in 1976 to that in 1991?
Keep it short and to the point. 0.07. What is the ratio of the Gross enrolment ratio (%) in Pre-primary schools in 1977 to that in 1979?
Your response must be concise. 0.82. What is the ratio of the Gross enrolment ratio (%) in Primary schools in 1977 to that in 1979?
Offer a terse response. 1.01. What is the ratio of the Gross enrolment ratio (%) of Secondary schools in 1977 to that in 1979?
Keep it short and to the point. 1.05. What is the ratio of the Gross enrolment ratio (%) of Tertiary schools in 1977 to that in 1979?
Provide a succinct answer. 0.06. What is the ratio of the Gross enrolment ratio (%) of Pre-primary schools in 1977 to that in 1990?
Offer a terse response. 0.72. What is the ratio of the Gross enrolment ratio (%) in Primary schools in 1977 to that in 1990?
Your answer should be compact. 1.09. What is the ratio of the Gross enrolment ratio (%) of Secondary schools in 1977 to that in 1990?
Provide a succinct answer. 1.09. What is the ratio of the Gross enrolment ratio (%) in Tertiary schools in 1977 to that in 1990?
Provide a succinct answer. 0.05. What is the ratio of the Gross enrolment ratio (%) of Pre-primary schools in 1977 to that in 1991?
Give a very brief answer. 0.67. What is the ratio of the Gross enrolment ratio (%) of Primary schools in 1977 to that in 1991?
Keep it short and to the point. 1.11. What is the ratio of the Gross enrolment ratio (%) in Secondary schools in 1977 to that in 1991?
Your answer should be very brief. 1.05. What is the ratio of the Gross enrolment ratio (%) in Tertiary schools in 1977 to that in 1991?
Make the answer very short. 0.05. What is the ratio of the Gross enrolment ratio (%) of Pre-primary schools in 1979 to that in 1990?
Provide a succinct answer. 0.88. What is the ratio of the Gross enrolment ratio (%) in Primary schools in 1979 to that in 1990?
Your answer should be compact. 1.08. What is the ratio of the Gross enrolment ratio (%) of Secondary schools in 1979 to that in 1990?
Ensure brevity in your answer.  1.04. What is the ratio of the Gross enrolment ratio (%) of Tertiary schools in 1979 to that in 1990?
Keep it short and to the point. 0.82. What is the ratio of the Gross enrolment ratio (%) of Pre-primary schools in 1979 to that in 1991?
Make the answer very short. 0.81. What is the ratio of the Gross enrolment ratio (%) of Primary schools in 1979 to that in 1991?
Your response must be concise. 1.1. What is the ratio of the Gross enrolment ratio (%) of Secondary schools in 1979 to that in 1991?
Give a very brief answer. 1. What is the ratio of the Gross enrolment ratio (%) in Tertiary schools in 1979 to that in 1991?
Offer a terse response. 0.9. What is the ratio of the Gross enrolment ratio (%) in Pre-primary schools in 1990 to that in 1991?
Your answer should be very brief. 0.93. What is the ratio of the Gross enrolment ratio (%) in Primary schools in 1990 to that in 1991?
Make the answer very short. 1.02. What is the ratio of the Gross enrolment ratio (%) of Secondary schools in 1990 to that in 1991?
Ensure brevity in your answer.  0.97. What is the ratio of the Gross enrolment ratio (%) in Tertiary schools in 1990 to that in 1991?
Your answer should be compact. 1.09. What is the difference between the highest and the second highest Gross enrolment ratio (%) of Pre-primary schools?
Offer a very short reply. 4.93. What is the difference between the highest and the second highest Gross enrolment ratio (%) of Primary schools?
Provide a succinct answer. 1.15. What is the difference between the highest and the second highest Gross enrolment ratio (%) of Secondary schools?
Your answer should be very brief. 1.12. What is the difference between the highest and the second highest Gross enrolment ratio (%) of Tertiary schools?
Provide a short and direct response. 0.66. What is the difference between the highest and the lowest Gross enrolment ratio (%) in Pre-primary schools?
Make the answer very short. 26.52. What is the difference between the highest and the lowest Gross enrolment ratio (%) in Primary schools?
Ensure brevity in your answer.  23.22. What is the difference between the highest and the lowest Gross enrolment ratio (%) in Secondary schools?
Give a very brief answer. 7.98. What is the difference between the highest and the lowest Gross enrolment ratio (%) in Tertiary schools?
Keep it short and to the point. 7.69. 